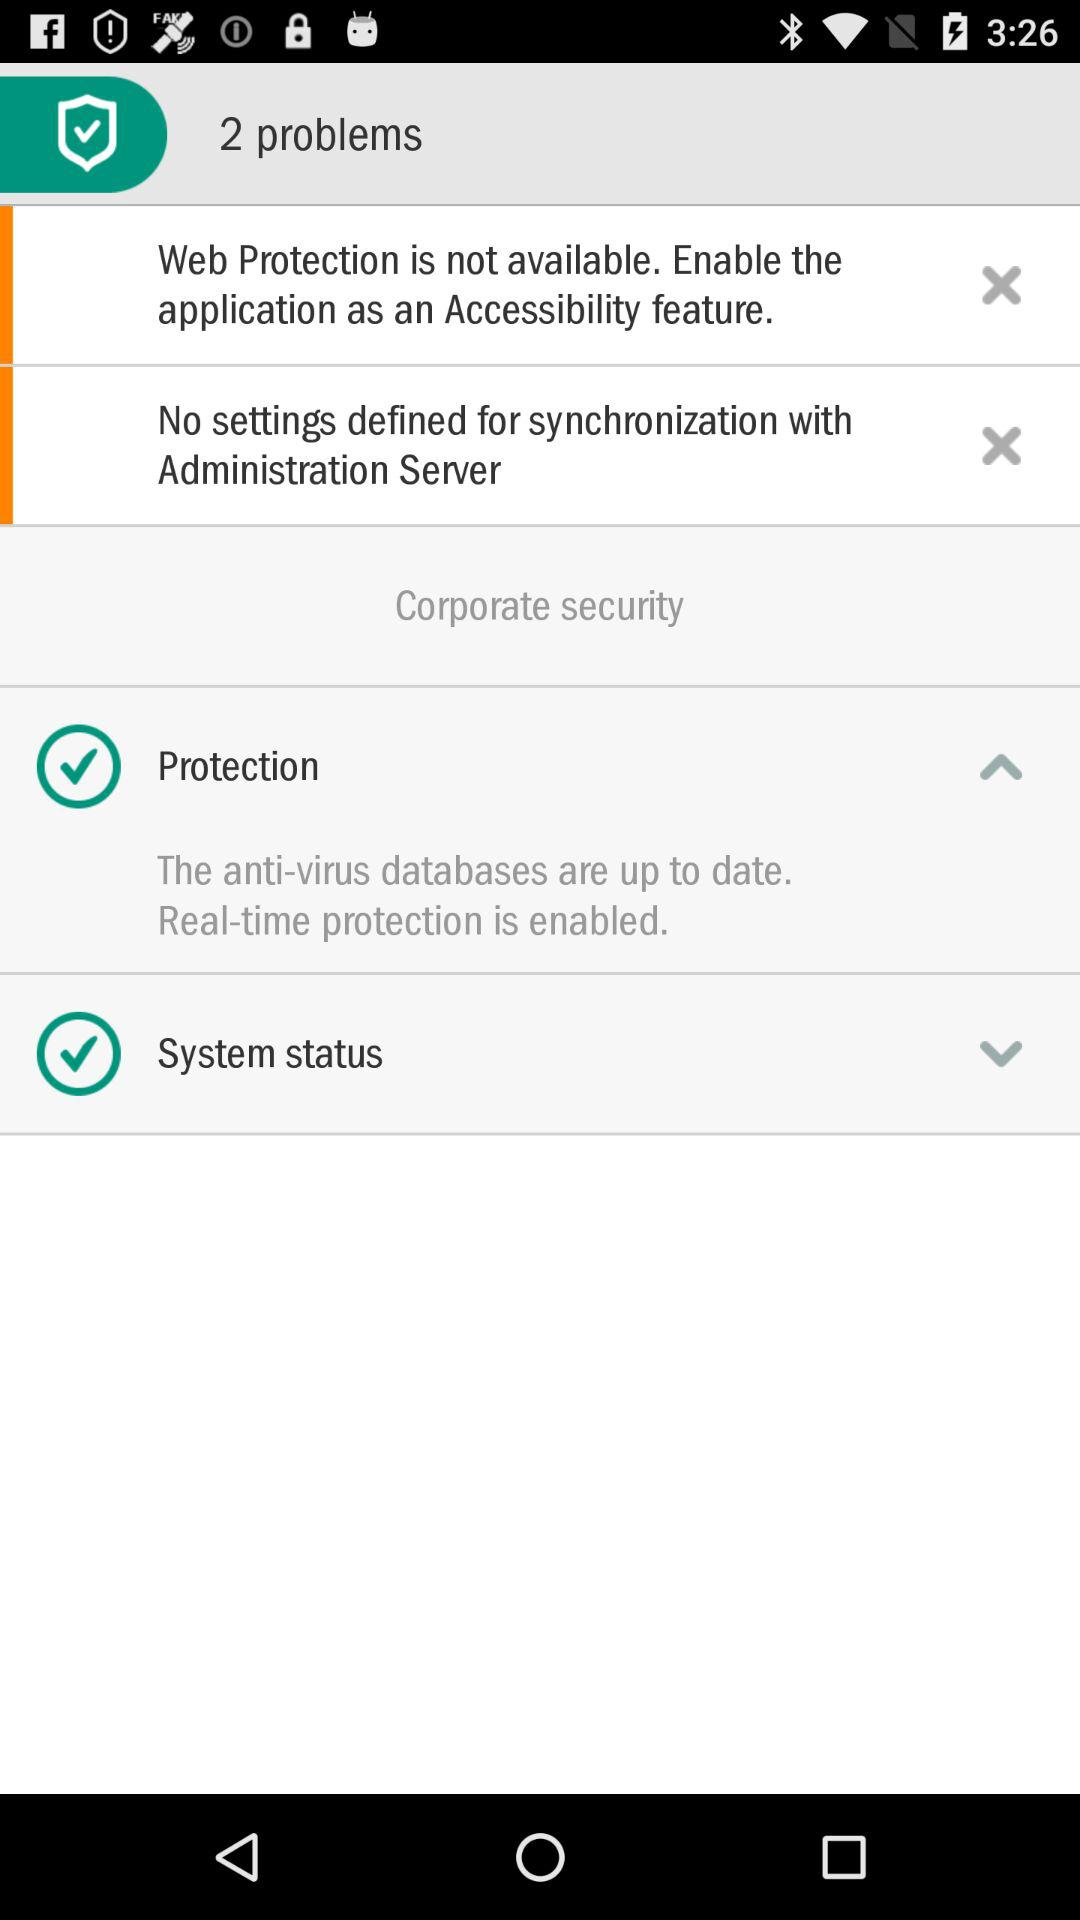How many problems are there in total?
Answer the question using a single word or phrase. 2 